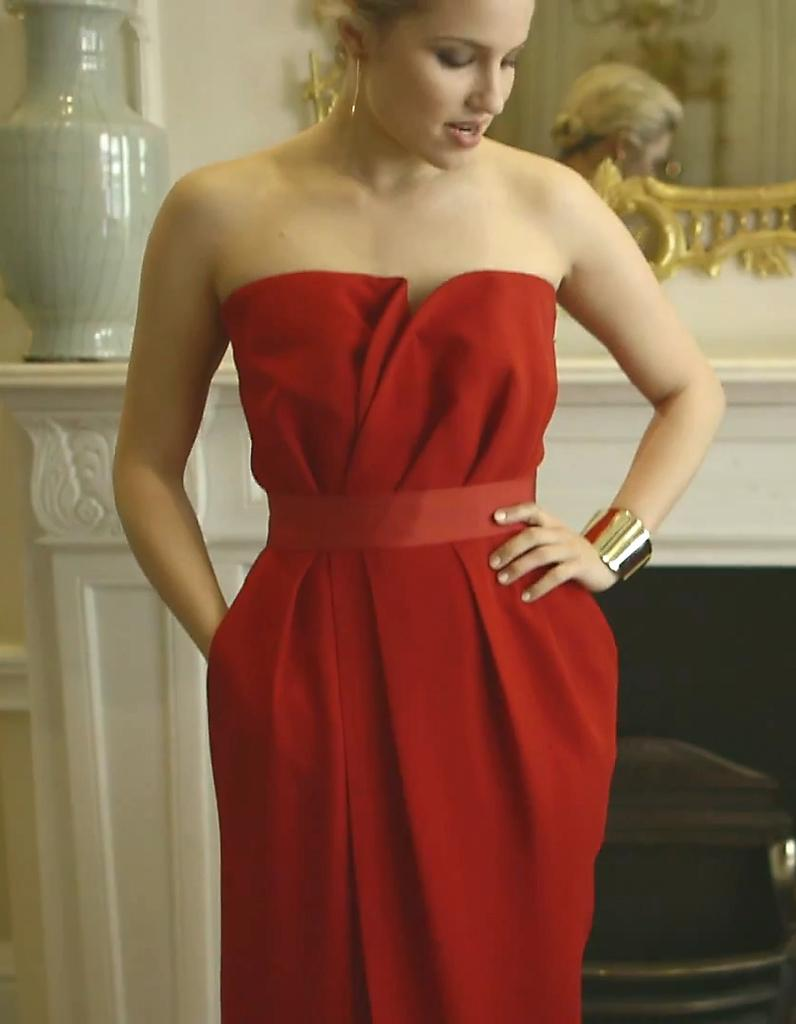What is the main subject in the image? There is a woman standing in the image. What can be seen in the background or near the woman? There is a vase and a mirror attached to the wall in the image. Can you describe any other objects in the image? Yes, there are some objects in the image. What type of knife is the woman using to teach in the image? There is no knife or teaching activity present in the image. 